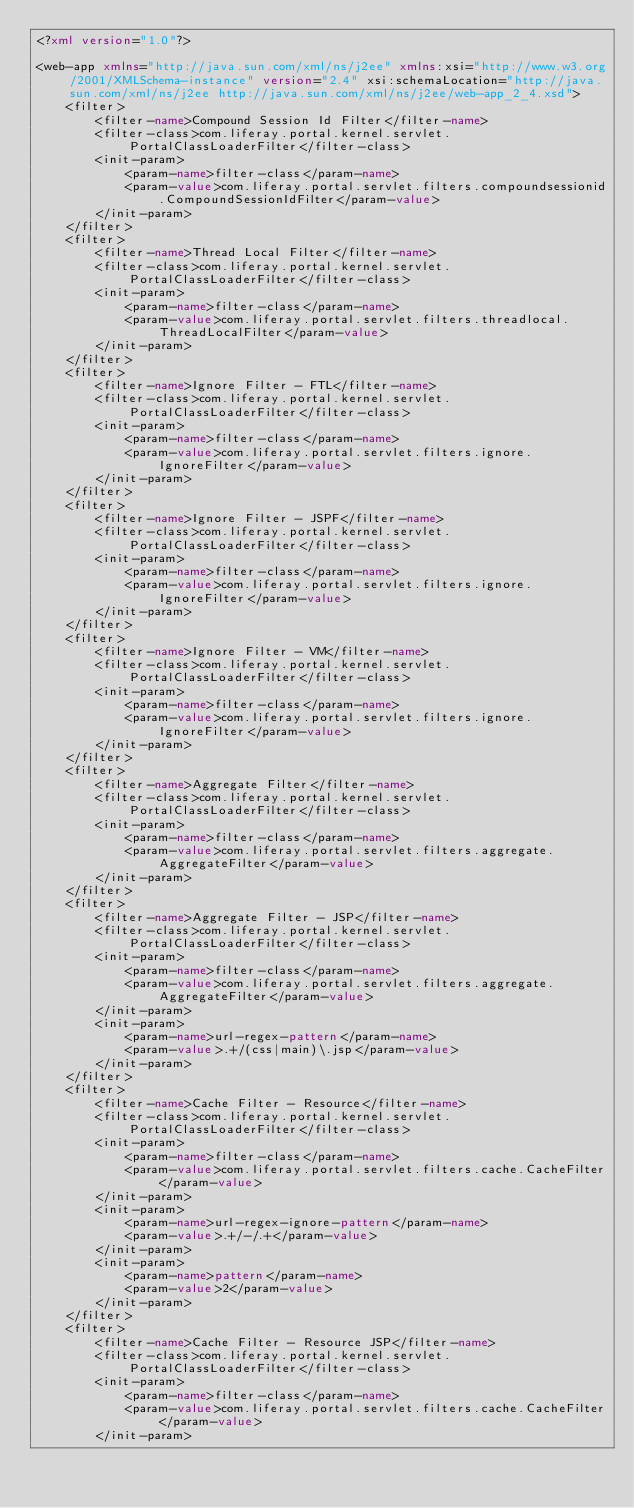<code> <loc_0><loc_0><loc_500><loc_500><_XML_><?xml version="1.0"?>

<web-app xmlns="http://java.sun.com/xml/ns/j2ee" xmlns:xsi="http://www.w3.org/2001/XMLSchema-instance" version="2.4" xsi:schemaLocation="http://java.sun.com/xml/ns/j2ee http://java.sun.com/xml/ns/j2ee/web-app_2_4.xsd">
	<filter>
		<filter-name>Compound Session Id Filter</filter-name>
		<filter-class>com.liferay.portal.kernel.servlet.PortalClassLoaderFilter</filter-class>
		<init-param>
			<param-name>filter-class</param-name>
			<param-value>com.liferay.portal.servlet.filters.compoundsessionid.CompoundSessionIdFilter</param-value>
		</init-param>
	</filter>
	<filter>
		<filter-name>Thread Local Filter</filter-name>
		<filter-class>com.liferay.portal.kernel.servlet.PortalClassLoaderFilter</filter-class>
		<init-param>
			<param-name>filter-class</param-name>
			<param-value>com.liferay.portal.servlet.filters.threadlocal.ThreadLocalFilter</param-value>
		</init-param>
	</filter>
	<filter>
		<filter-name>Ignore Filter - FTL</filter-name>
		<filter-class>com.liferay.portal.kernel.servlet.PortalClassLoaderFilter</filter-class>
		<init-param>
			<param-name>filter-class</param-name>
			<param-value>com.liferay.portal.servlet.filters.ignore.IgnoreFilter</param-value>
		</init-param>
	</filter>
	<filter>
		<filter-name>Ignore Filter - JSPF</filter-name>
		<filter-class>com.liferay.portal.kernel.servlet.PortalClassLoaderFilter</filter-class>
		<init-param>
			<param-name>filter-class</param-name>
			<param-value>com.liferay.portal.servlet.filters.ignore.IgnoreFilter</param-value>
		</init-param>
	</filter>
	<filter>
		<filter-name>Ignore Filter - VM</filter-name>
		<filter-class>com.liferay.portal.kernel.servlet.PortalClassLoaderFilter</filter-class>
		<init-param>
			<param-name>filter-class</param-name>
			<param-value>com.liferay.portal.servlet.filters.ignore.IgnoreFilter</param-value>
		</init-param>
	</filter>
	<filter>
		<filter-name>Aggregate Filter</filter-name>
		<filter-class>com.liferay.portal.kernel.servlet.PortalClassLoaderFilter</filter-class>
		<init-param>
			<param-name>filter-class</param-name>
			<param-value>com.liferay.portal.servlet.filters.aggregate.AggregateFilter</param-value>
		</init-param>
	</filter>
	<filter>
		<filter-name>Aggregate Filter - JSP</filter-name>
		<filter-class>com.liferay.portal.kernel.servlet.PortalClassLoaderFilter</filter-class>
		<init-param>
			<param-name>filter-class</param-name>
			<param-value>com.liferay.portal.servlet.filters.aggregate.AggregateFilter</param-value>
		</init-param>
		<init-param>
			<param-name>url-regex-pattern</param-name>
			<param-value>.+/(css|main)\.jsp</param-value>
		</init-param>
	</filter>
	<filter>
		<filter-name>Cache Filter - Resource</filter-name>
		<filter-class>com.liferay.portal.kernel.servlet.PortalClassLoaderFilter</filter-class>
		<init-param>
			<param-name>filter-class</param-name>
			<param-value>com.liferay.portal.servlet.filters.cache.CacheFilter</param-value>
		</init-param>
		<init-param>
			<param-name>url-regex-ignore-pattern</param-name>
			<param-value>.+/-/.+</param-value>
		</init-param>
		<init-param>
			<param-name>pattern</param-name>
			<param-value>2</param-value>
		</init-param>
	</filter>
	<filter>
		<filter-name>Cache Filter - Resource JSP</filter-name>
		<filter-class>com.liferay.portal.kernel.servlet.PortalClassLoaderFilter</filter-class>
		<init-param>
			<param-name>filter-class</param-name>
			<param-value>com.liferay.portal.servlet.filters.cache.CacheFilter</param-value>
		</init-param></code> 